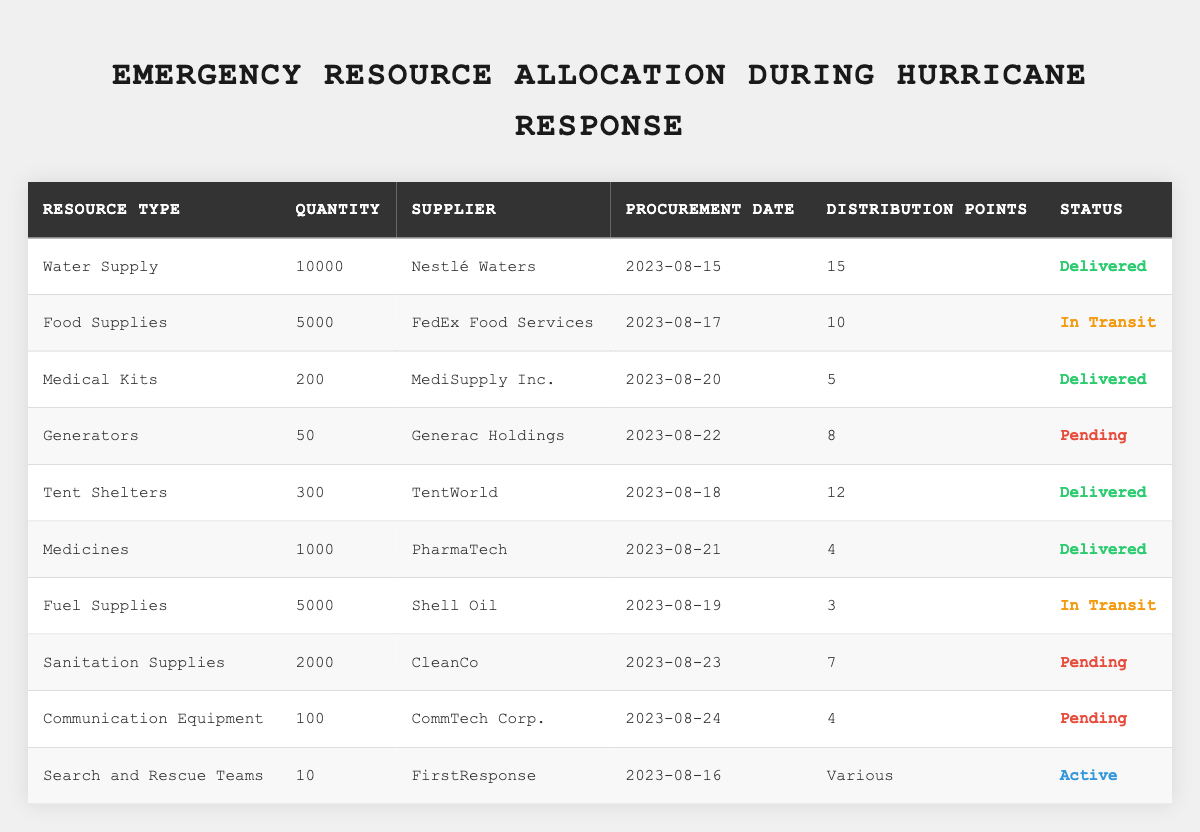What is the total quantity of Water Supply allocated? The table shows the quantity of Water Supply allocated as 10,000.
Answer: 10,000 Who supplied the Medical Kits? The table lists MediSupply Inc. as the supplier for Medical Kits.
Answer: MediSupply Inc How many distribution points are there for Food Supplies? According to the table, there are 10 distribution points for Food Supplies.
Answer: 10 What is the status of the Fuel Supplies? The table indicates that the status of the Fuel Supplies is "In Transit."
Answer: In Transit Are there any resources that are currently pending? Yes, the table shows Generators, Sanitation Supplies, and Communication Equipment as pending.
Answer: Yes What is the total number of resources listed in the table? There are 10 resources listed in the table.
Answer: 10 What is the procurement date for the Tent Shelters? The procurement date for Tent Shelters is August 18, 2023.
Answer: 2023-08-18 How many distribution points are associated with Medicines? The table indicates that there are 4 distribution points for Medicines.
Answer: 4 What is the status of the resources supplied by CleanCo? CleanCo is supplying Sanitation Supplies, which is listed as pending in the table.
Answer: Pending Which resource has the highest quantity? Water Supply has the highest quantity with 10,000 reported in the table.
Answer: Water Supply What is the average quantity of resources that have been delivered? The delivered resources are Water Supply (10,000), Medical Kits (200), Tent Shelters (300), and Medicines (1,000), giving a total of 11,500 for 4 items; hence, the average is 11,500/4 = 2,875.
Answer: 2,875 Is there any resource that is supplied by Generac Holdings? Yes, Generators are supplied by Generac Holdings as per the table.
Answer: Yes What is the difference in quantity between the Food Supplies and Generators? The quantity of Food Supplies is 5,000 and Generators is 50, so the difference is 5,000 - 50 = 4,950.
Answer: 4,950 Which resource is labeled as 'Active'? The Search and Rescue Teams are labeled as 'Active' in the table.
Answer: Search and Rescue Teams How many resources are either delivered or currently in transit? The delivered resources are Water Supply, Medical Kits, Tent Shelters, and Medicines (4 total), while the in transit resources are Food Supplies and Fuel Supplies (2 total), giving a total of 4 + 2 = 6.
Answer: 6 What percentage of the total resources listed have already been delivered? There are 10 total resources. 4 are delivered, so the percentage is (4/10) * 100 = 40%.
Answer: 40% 